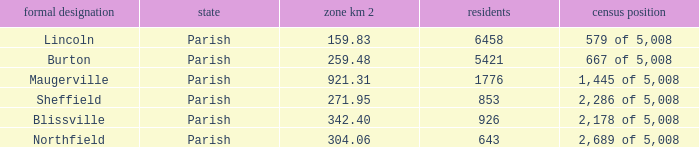What are the official name(s) of places with an area of 304.06 km2? Northfield. 